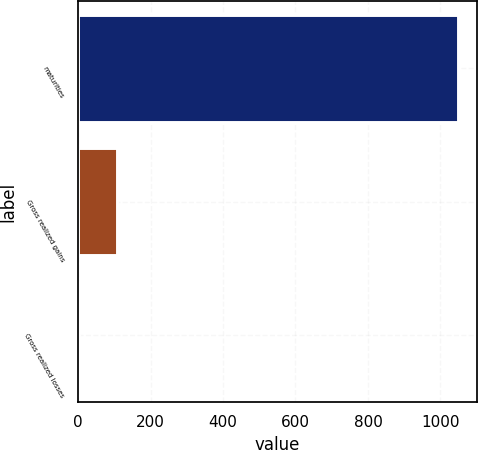<chart> <loc_0><loc_0><loc_500><loc_500><bar_chart><fcel>maturities<fcel>Gross realized gains<fcel>Gross realized losses<nl><fcel>1048<fcel>106.6<fcel>2<nl></chart> 